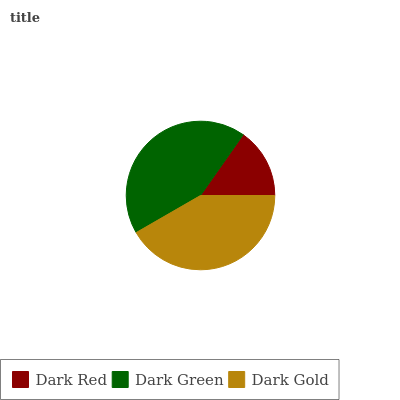Is Dark Red the minimum?
Answer yes or no. Yes. Is Dark Green the maximum?
Answer yes or no. Yes. Is Dark Gold the minimum?
Answer yes or no. No. Is Dark Gold the maximum?
Answer yes or no. No. Is Dark Green greater than Dark Gold?
Answer yes or no. Yes. Is Dark Gold less than Dark Green?
Answer yes or no. Yes. Is Dark Gold greater than Dark Green?
Answer yes or no. No. Is Dark Green less than Dark Gold?
Answer yes or no. No. Is Dark Gold the high median?
Answer yes or no. Yes. Is Dark Gold the low median?
Answer yes or no. Yes. Is Dark Green the high median?
Answer yes or no. No. Is Dark Green the low median?
Answer yes or no. No. 